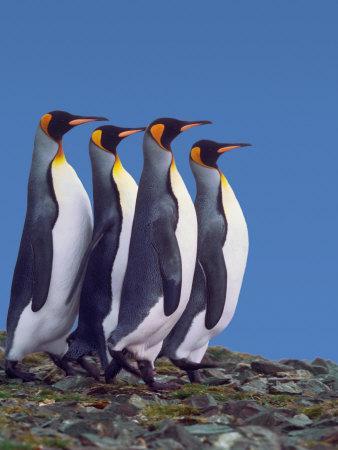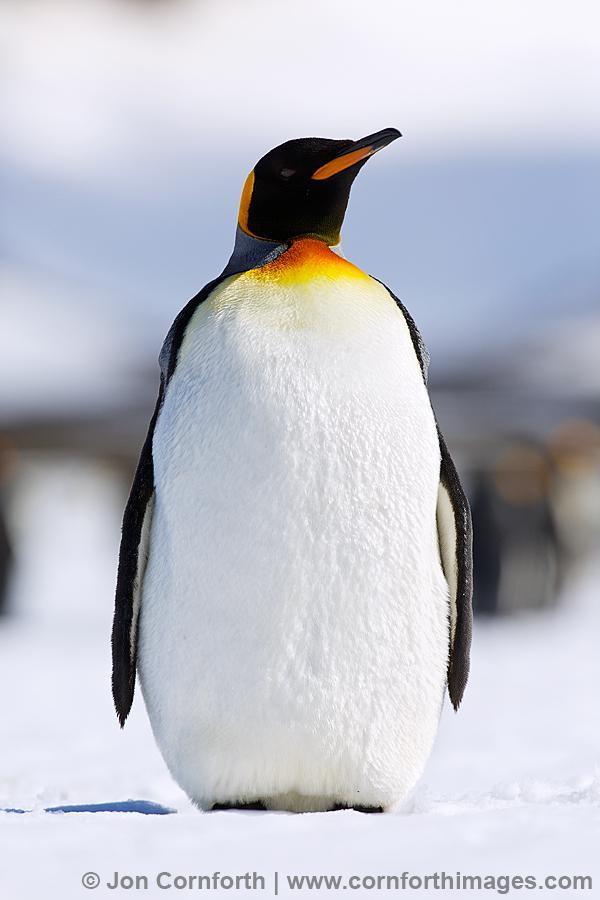The first image is the image on the left, the second image is the image on the right. Given the left and right images, does the statement "An image contains at least three penguins in the foreground, and all of them face in different directions." hold true? Answer yes or no. No. The first image is the image on the left, the second image is the image on the right. Analyze the images presented: Is the assertion "There are five penguins" valid? Answer yes or no. Yes. The first image is the image on the left, the second image is the image on the right. Analyze the images presented: Is the assertion "The right image contains no more than one penguin." valid? Answer yes or no. Yes. 